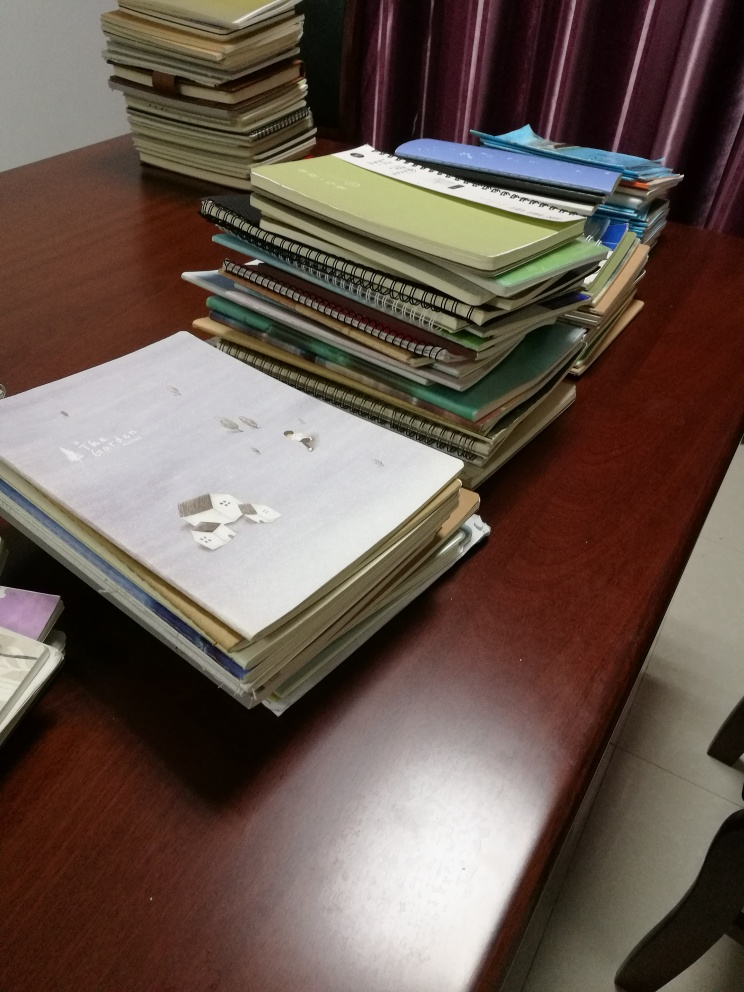What does this image imply about the person who uses the desk? The desk gives the impression of being used by someone who juggles multiple tasks or projects, as suggested by the variety of notebooks and papers. It is likely to belong to a student, academic, or professional who requires extensive note-taking and referencing, indicative of disciplined and intellectual work. 